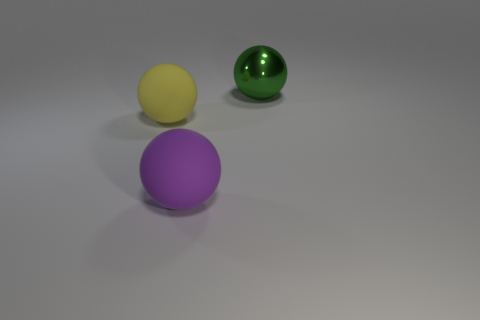What number of things are either things that are on the right side of the yellow thing or spheres on the left side of the green shiny thing?
Your response must be concise. 3. Are there fewer yellow balls than big balls?
Give a very brief answer. Yes. Are there any yellow things in front of the green thing?
Your answer should be compact. Yes. Are the large yellow ball and the big purple thing made of the same material?
Provide a succinct answer. Yes. There is another big rubber thing that is the same shape as the large purple thing; what is its color?
Offer a very short reply. Yellow. How many big purple things have the same material as the yellow ball?
Keep it short and to the point. 1. There is a metallic thing; how many big purple balls are behind it?
Offer a very short reply. 0. What is the size of the shiny thing?
Your response must be concise. Large. The metallic sphere that is the same size as the yellow rubber ball is what color?
Your response must be concise. Green. What material is the green ball?
Keep it short and to the point. Metal. 